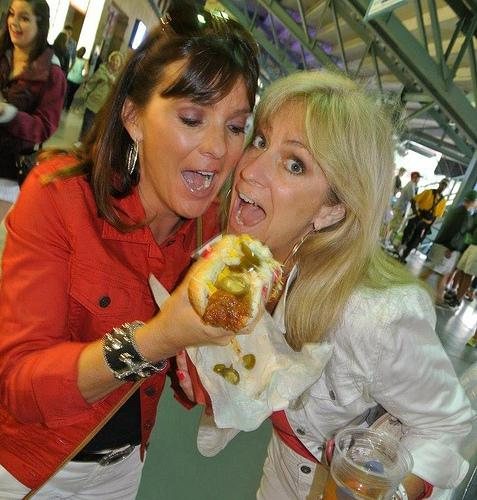Question: what does the person on left side of photo have in hand?
Choices:
A. Cellphone.
B. Camera.
C. Hotdog.
D. Baby.
Answer with the letter. Answer: C Question: where is the person on right side of photo holding drink?
Choices:
A. Lap.
B. Right foot.
C. Left hand.
D. Head.
Answer with the letter. Answer: C Question: how was this hot dog apparently wrapped when purchased?
Choices:
A. In plastic.
B. In dirt.
C. In blanket.
D. In paper.
Answer with the letter. Answer: D Question: what might the green items on hot dog be?
Choices:
A. Spinach.
B. Tomato.
C. Pepper.
D. Pickles.
Answer with the letter. Answer: D Question: what yellow condiment is seen on hot dog?
Choices:
A. Squash.
B. Peppers.
C. Bananas.
D. Mustard.
Answer with the letter. Answer: D Question: who are the two people in photo with hotdog?
Choices:
A. Men.
B. Kids.
C. Women.
D. Harold and Maude.
Answer with the letter. Answer: C 